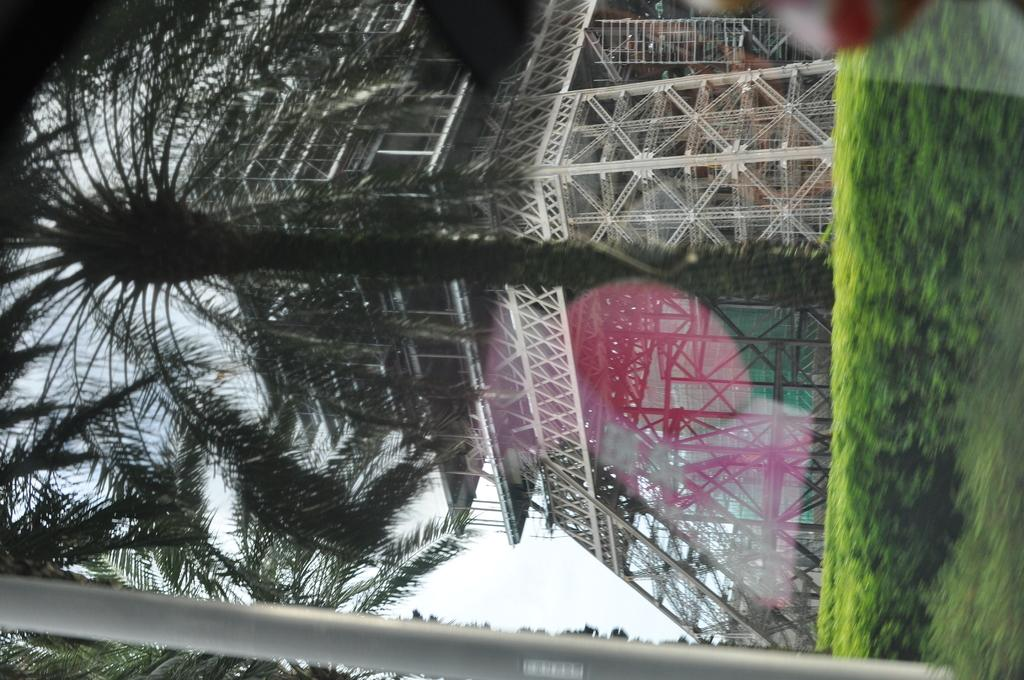What is the main subject of the image? The main subject of the image is a building under construction. What can be seen in the background of the image? There are trees and plants in the image. How many accounts are visible in the image? There are no accounts present in the image. What type of birds can be seen in the image? There are no birds present in the image. 